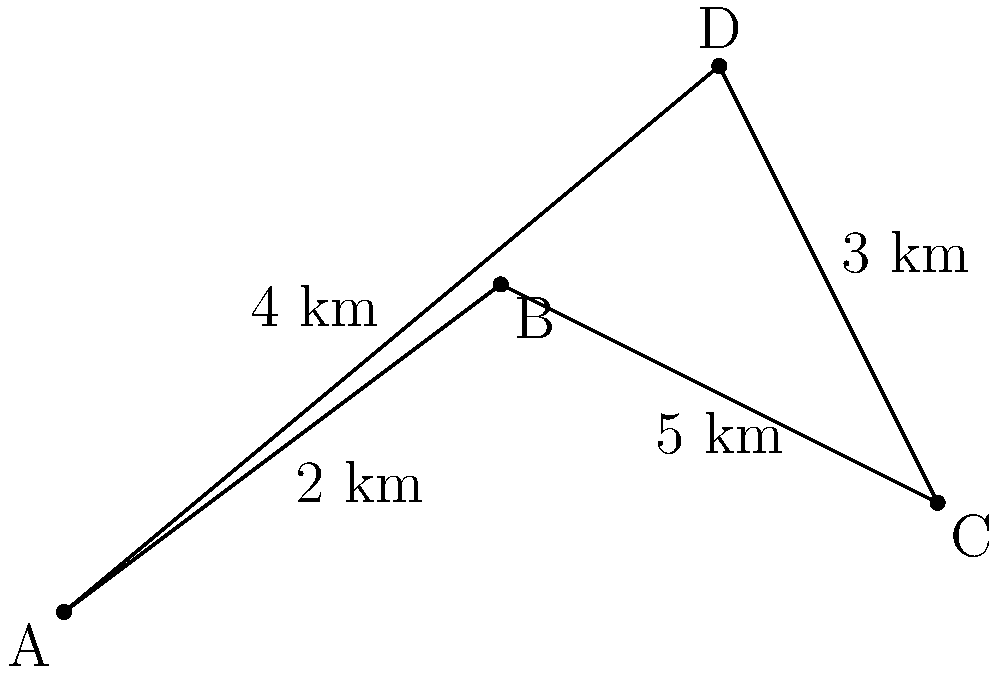As a retired postman, you're helping train new mail carriers on efficient route planning. Given the map above representing a neighborhood with four delivery points (A, B, C, and D) and the distances between them, what is the shortest possible route that visits all points and returns to the starting point? Assume you can start at any point. To find the shortest route, we need to consider all possible paths that visit each point once and return to the starting point. This is known as the Traveling Salesman Problem.

Step 1: List all possible routes:
1. A-B-C-D-A
2. A-B-D-C-A
3. A-C-B-D-A
4. A-C-D-B-A
5. A-D-B-C-A
6. A-D-C-B-A

Step 2: Calculate the distance for each route:
1. A-B-C-D-A = 2 + 5 + 3 + 4 = 14 km
2. A-B-D-C-A = 2 + $\sqrt{2^2 + 2^2}$ + 3 + 5 = $10 + \sqrt{8}$ km
3. A-C-B-D-A = 5 + 5 + $\sqrt{2^2 + 2^2}$ + 4 = $14 + \sqrt{8}$ km
4. A-C-D-B-A = 5 + 3 + $\sqrt{2^2 + 2^2}$ + 2 = $10 + \sqrt{8}$ km
5. A-D-B-C-A = 4 + $\sqrt{2^2 + 2^2}$ + 5 + 5 = $14 + \sqrt{8}$ km
6. A-D-C-B-A = 4 + 3 + 5 + 2 = 14 km

Step 3: Identify the shortest route:
The shortest routes are A-B-D-C-A and A-C-D-B-A, both with a distance of $10 + \sqrt{8}$ km.

Step 4: Convert to a more precise value:
$10 + \sqrt{8} \approx 12.83$ km
Answer: $10 + \sqrt{8}$ km (approximately 12.83 km) 